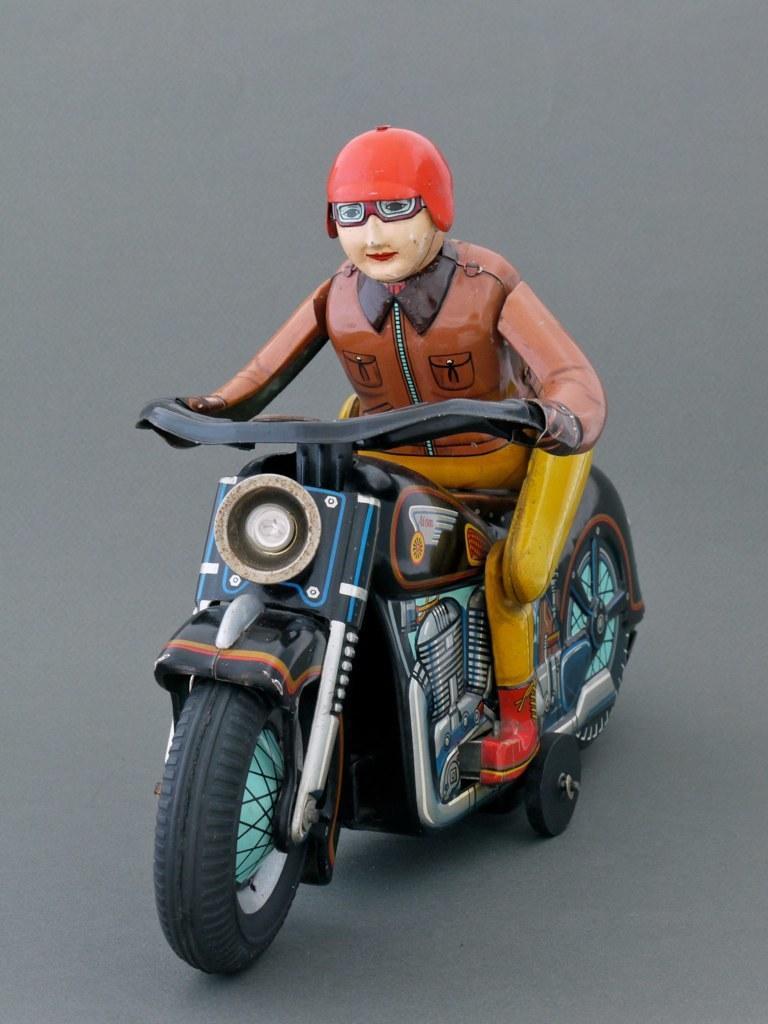Please provide a concise description of this image. In the center of the picture we can see a toy, in which a person is sitting on a bike. At the bottom it is grey. 